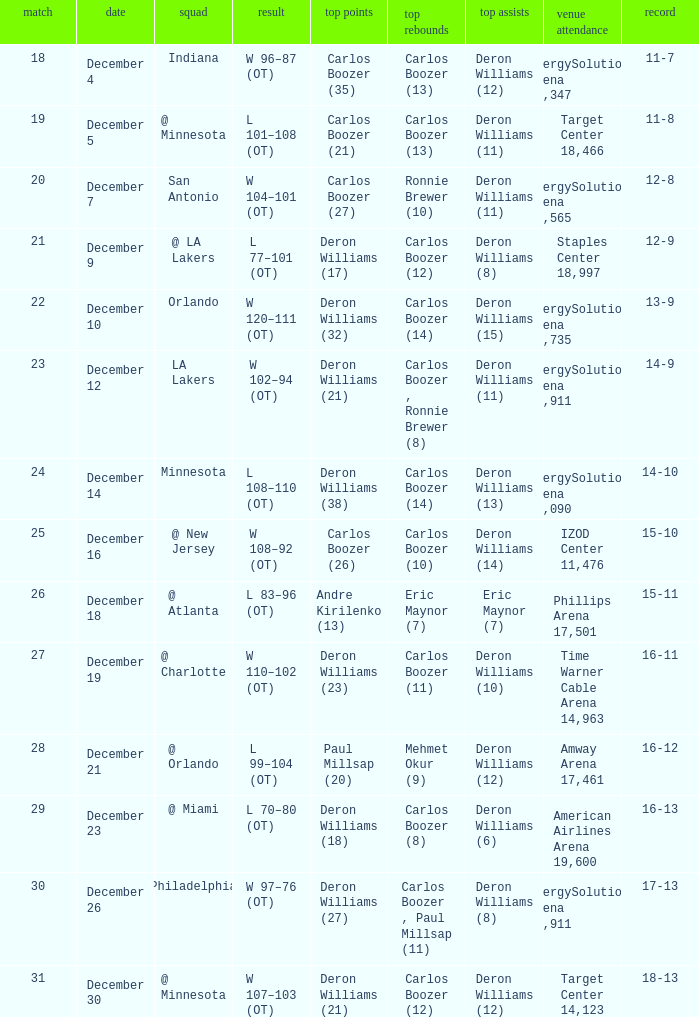How many different high rebound results are there for the game number 26? 1.0. 